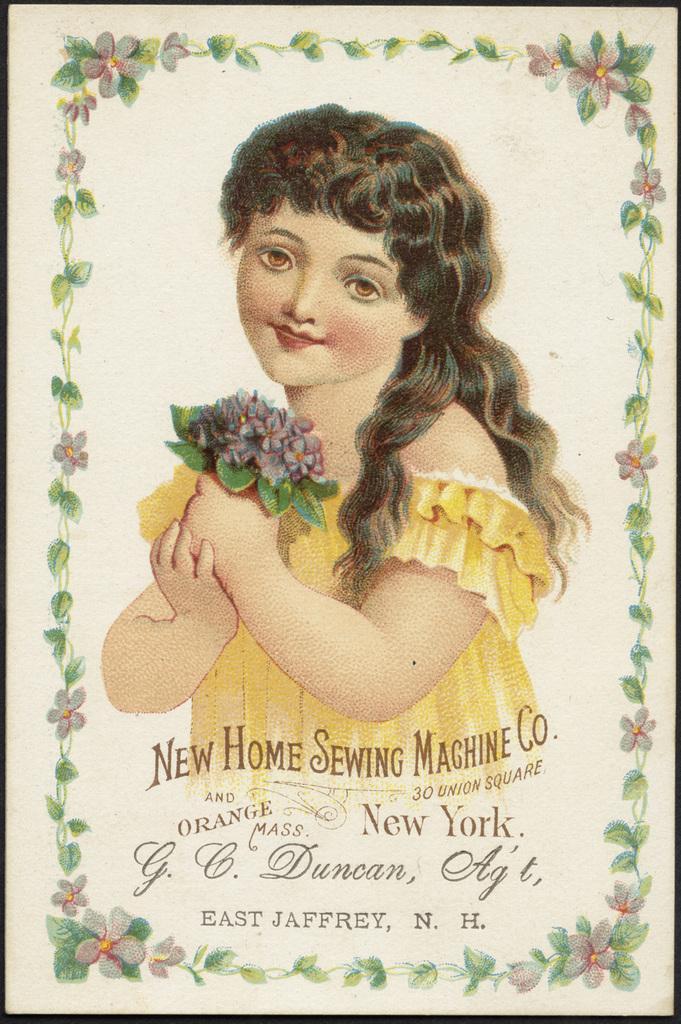Can you describe this image briefly? In this picture we can see a paper, there is a painting of a person, flowers and design on this paper, we can see some text at the bottom. 